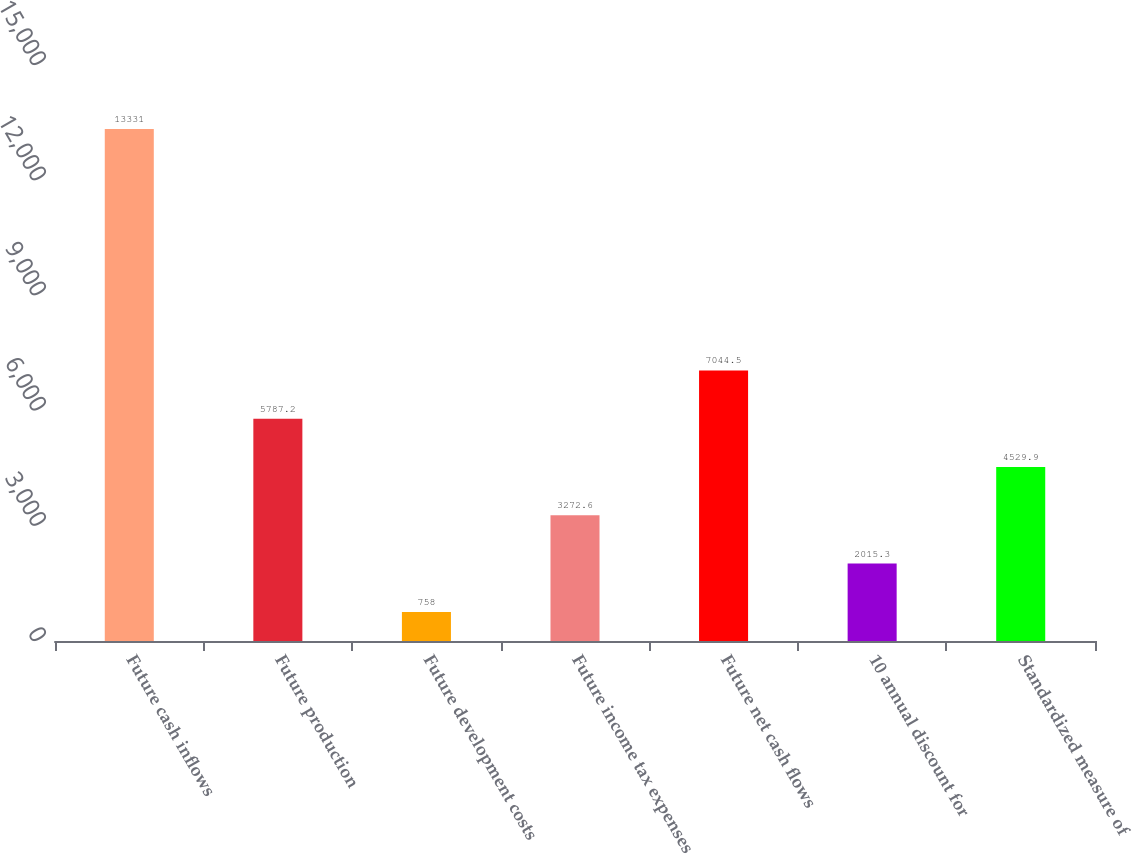Convert chart. <chart><loc_0><loc_0><loc_500><loc_500><bar_chart><fcel>Future cash inflows<fcel>Future production<fcel>Future development costs<fcel>Future income tax expenses<fcel>Future net cash flows<fcel>10 annual discount for<fcel>Standardized measure of<nl><fcel>13331<fcel>5787.2<fcel>758<fcel>3272.6<fcel>7044.5<fcel>2015.3<fcel>4529.9<nl></chart> 